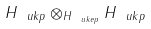Convert formula to latex. <formula><loc_0><loc_0><loc_500><loc_500>H _ { \ u k p } \otimes _ { H _ { \ u k e p } } H _ { \ u k p }</formula> 